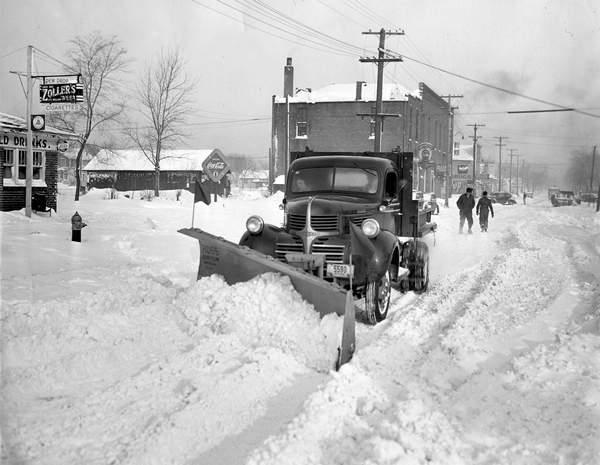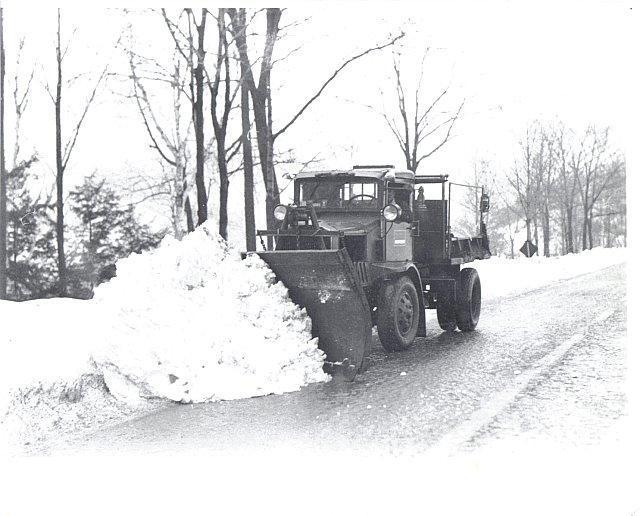The first image is the image on the left, the second image is the image on the right. Given the left and right images, does the statement "It is actively snowing in at least one of the images." hold true? Answer yes or no. No. The first image is the image on the left, the second image is the image on the right. Given the left and right images, does the statement "Each image shows a front-facing truck pushing a snowplow on a snow-covered surface." hold true? Answer yes or no. Yes. 